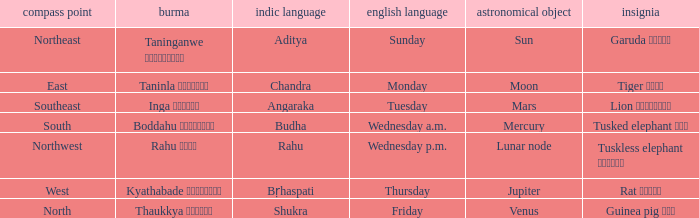What is the Burmese term associated with a cardinal direction of west? Kyathabade ကြာသပတေး. 